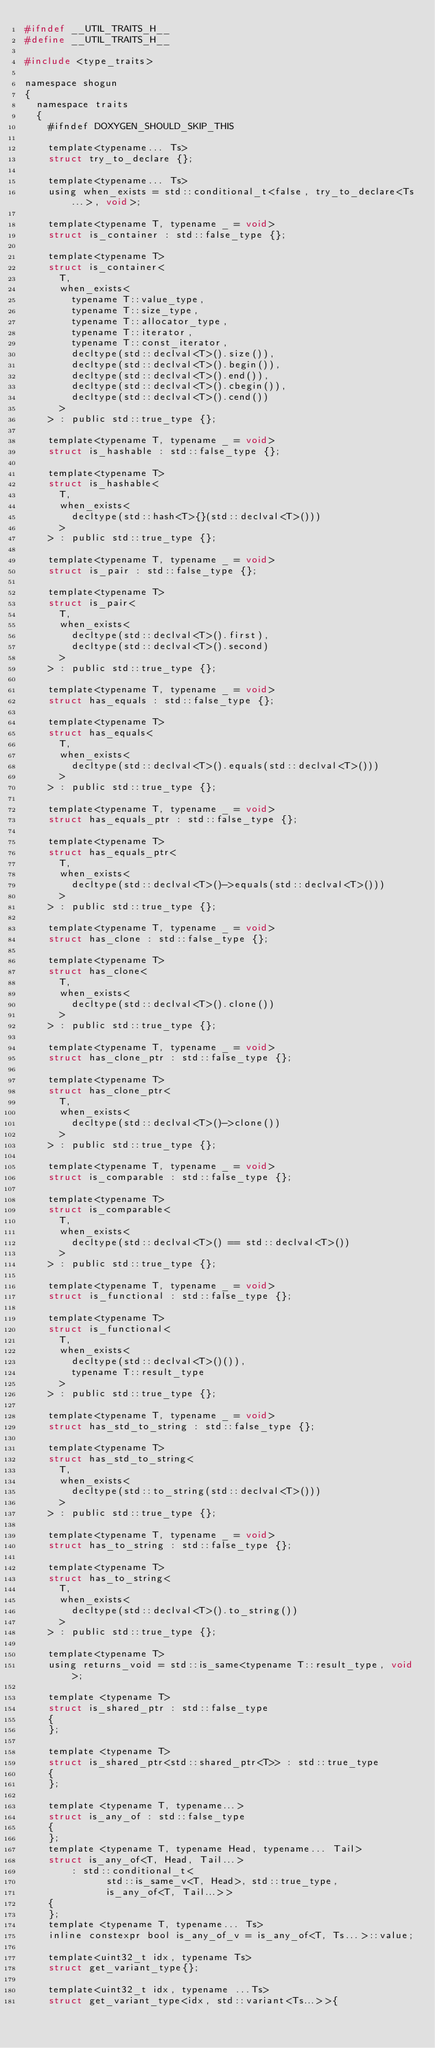Convert code to text. <code><loc_0><loc_0><loc_500><loc_500><_C_>#ifndef __UTIL_TRAITS_H__
#define __UTIL_TRAITS_H__

#include <type_traits>

namespace shogun
{
	namespace traits
	{
		#ifndef DOXYGEN_SHOULD_SKIP_THIS

		template<typename... Ts>
		struct try_to_declare {};

		template<typename... Ts>
		using when_exists = std::conditional_t<false, try_to_declare<Ts...>, void>;

		template<typename T, typename _ = void>
		struct is_container : std::false_type {};

		template<typename T>
		struct is_container<
			T,
			when_exists<
				typename T::value_type,
				typename T::size_type,
				typename T::allocator_type,
				typename T::iterator,
				typename T::const_iterator,
				decltype(std::declval<T>().size()),
				decltype(std::declval<T>().begin()),
				decltype(std::declval<T>().end()),
				decltype(std::declval<T>().cbegin()),
				decltype(std::declval<T>().cend())
			>
		> : public std::true_type {};

		template<typename T, typename _ = void>
		struct is_hashable : std::false_type {};

		template<typename T>
		struct is_hashable<
			T,
			when_exists<
				decltype(std::hash<T>{}(std::declval<T>()))
			>
		> : public std::true_type {};

		template<typename T, typename _ = void>
		struct is_pair : std::false_type {};

		template<typename T>
		struct is_pair<
			T,
			when_exists<
				decltype(std::declval<T>().first),
				decltype(std::declval<T>().second)
			>
		> : public std::true_type {};

		template<typename T, typename _ = void>
		struct has_equals : std::false_type {};

		template<typename T>
		struct has_equals<
			T,
			when_exists<
				decltype(std::declval<T>().equals(std::declval<T>()))
			>
		> : public std::true_type {};

		template<typename T, typename _ = void>
		struct has_equals_ptr : std::false_type {};

		template<typename T>
		struct has_equals_ptr<
			T,
			when_exists<
				decltype(std::declval<T>()->equals(std::declval<T>()))
			>
		> : public std::true_type {};

		template<typename T, typename _ = void>
		struct has_clone : std::false_type {};

		template<typename T>
		struct has_clone<
			T,
			when_exists<
				decltype(std::declval<T>().clone())
			>
		> : public std::true_type {};

		template<typename T, typename _ = void>
		struct has_clone_ptr : std::false_type {};

		template<typename T>
		struct has_clone_ptr<
			T,
			when_exists<
				decltype(std::declval<T>()->clone())
			>
		> : public std::true_type {};

		template<typename T, typename _ = void>
		struct is_comparable : std::false_type {};

		template<typename T>
		struct is_comparable<
			T,
			when_exists<
				decltype(std::declval<T>() == std::declval<T>())
			>
		> : public std::true_type {};

		template<typename T, typename _ = void>
		struct is_functional : std::false_type {};

		template<typename T>
		struct is_functional<
			T,
			when_exists<
				decltype(std::declval<T>()()),
				typename T::result_type
			>
		> : public std::true_type {};

		template<typename T, typename _ = void>
		struct has_std_to_string : std::false_type {};

		template<typename T>
		struct has_std_to_string<
			T,
			when_exists<
				decltype(std::to_string(std::declval<T>()))
			>
		> : public std::true_type {};

		template<typename T, typename _ = void>
		struct has_to_string : std::false_type {};

		template<typename T>
		struct has_to_string<
			T,
			when_exists<
				decltype(std::declval<T>().to_string())
			>
		> : public std::true_type {};

		template<typename T>
		using returns_void = std::is_same<typename T::result_type, void>;

		template <typename T>
		struct is_shared_ptr : std::false_type
		{
		};

		template <typename T>
		struct is_shared_ptr<std::shared_ptr<T>> : std::true_type
		{
		};

		template <typename T, typename...>
		struct is_any_of : std::false_type
		{
		};
		template <typename T, typename Head, typename... Tail>
		struct is_any_of<T, Head, Tail...>
		    : std::conditional_t<
		          std::is_same_v<T, Head>, std::true_type,
		          is_any_of<T, Tail...>>
		{
		};
		template <typename T, typename... Ts>
		inline constexpr bool is_any_of_v = is_any_of<T, Ts...>::value;

		template<uint32_t idx, typename Ts>
		struct get_variant_type{};

		template<uint32_t idx, typename ...Ts>
		struct get_variant_type<idx, std::variant<Ts...>>{</code> 